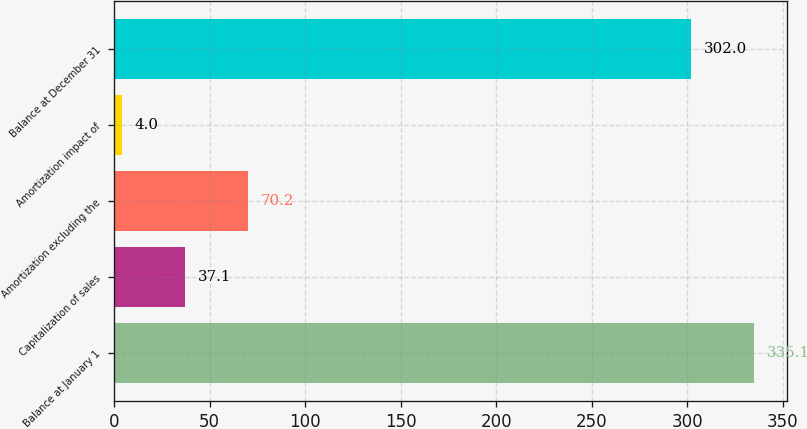Convert chart to OTSL. <chart><loc_0><loc_0><loc_500><loc_500><bar_chart><fcel>Balance at January 1<fcel>Capitalization of sales<fcel>Amortization excluding the<fcel>Amortization impact of<fcel>Balance at December 31<nl><fcel>335.1<fcel>37.1<fcel>70.2<fcel>4<fcel>302<nl></chart> 